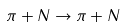<formula> <loc_0><loc_0><loc_500><loc_500>\pi + N \to \pi + N</formula> 